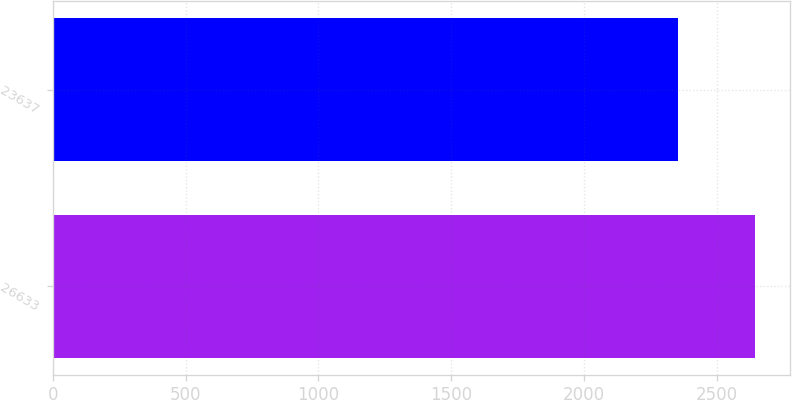Convert chart to OTSL. <chart><loc_0><loc_0><loc_500><loc_500><bar_chart><fcel>26633<fcel>23637<nl><fcel>2641.9<fcel>2353.8<nl></chart> 